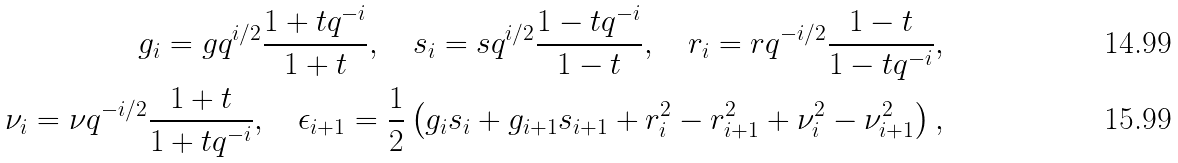<formula> <loc_0><loc_0><loc_500><loc_500>g _ { i } = g q ^ { i / 2 } \frac { 1 + t q ^ { - i } } { 1 + t } , \quad s _ { i } = s q ^ { i / 2 } \frac { 1 - t q ^ { - i } } { 1 - t } , \quad r _ { i } = r q ^ { - i / 2 } \frac { 1 - t } { 1 - t q ^ { - i } } , \\ \nu _ { i } = \nu q ^ { - i / 2 } \frac { 1 + t } { 1 + t q ^ { - i } } , \quad \epsilon _ { i + 1 } = \frac { 1 } { 2 } \left ( g _ { i } s _ { i } + g _ { i + 1 } s _ { i + 1 } + r _ { i } ^ { 2 } - r _ { i + 1 } ^ { 2 } + \nu _ { i } ^ { 2 } - \nu _ { i + 1 } ^ { 2 } \right ) ,</formula> 